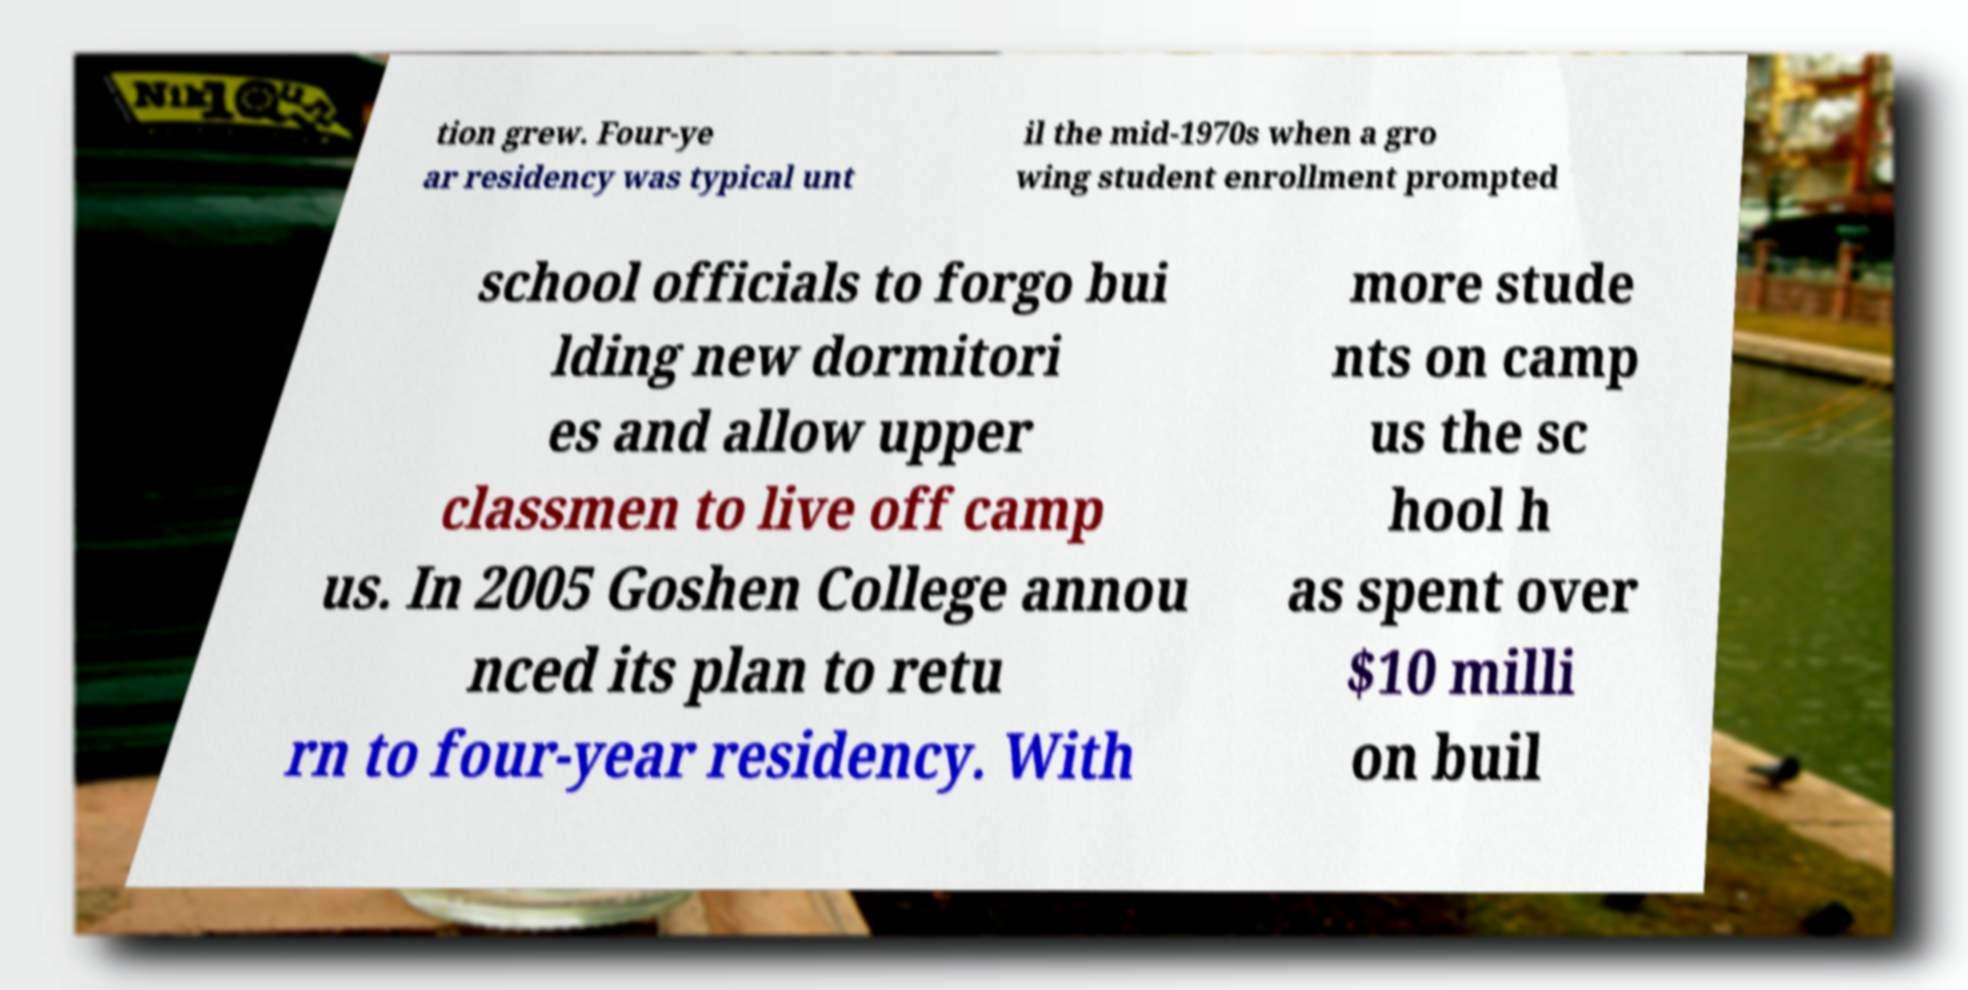For documentation purposes, I need the text within this image transcribed. Could you provide that? tion grew. Four-ye ar residency was typical unt il the mid-1970s when a gro wing student enrollment prompted school officials to forgo bui lding new dormitori es and allow upper classmen to live off camp us. In 2005 Goshen College annou nced its plan to retu rn to four-year residency. With more stude nts on camp us the sc hool h as spent over $10 milli on buil 